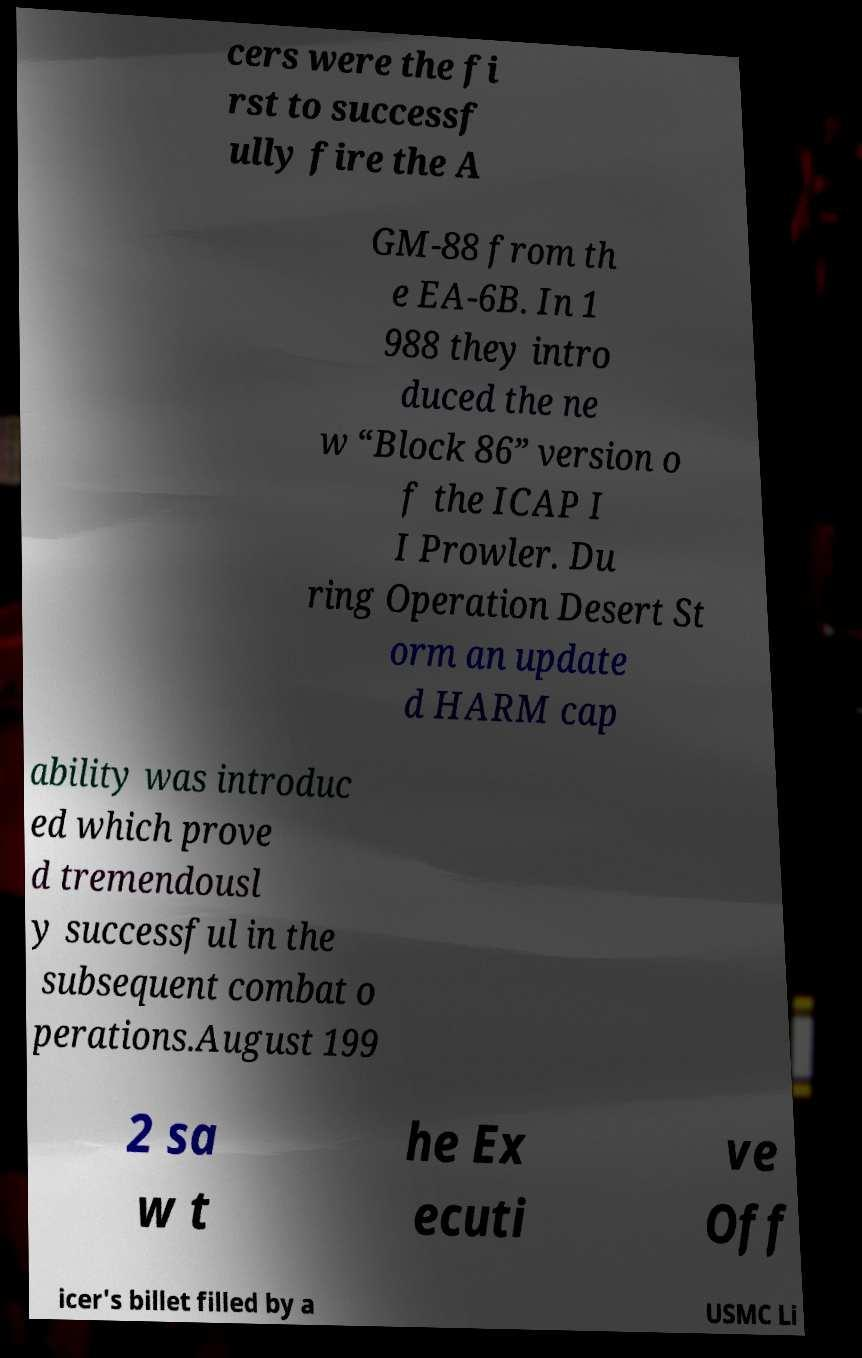Could you extract and type out the text from this image? cers were the fi rst to successf ully fire the A GM-88 from th e EA-6B. In 1 988 they intro duced the ne w “Block 86” version o f the ICAP I I Prowler. Du ring Operation Desert St orm an update d HARM cap ability was introduc ed which prove d tremendousl y successful in the subsequent combat o perations.August 199 2 sa w t he Ex ecuti ve Off icer's billet filled by a USMC Li 